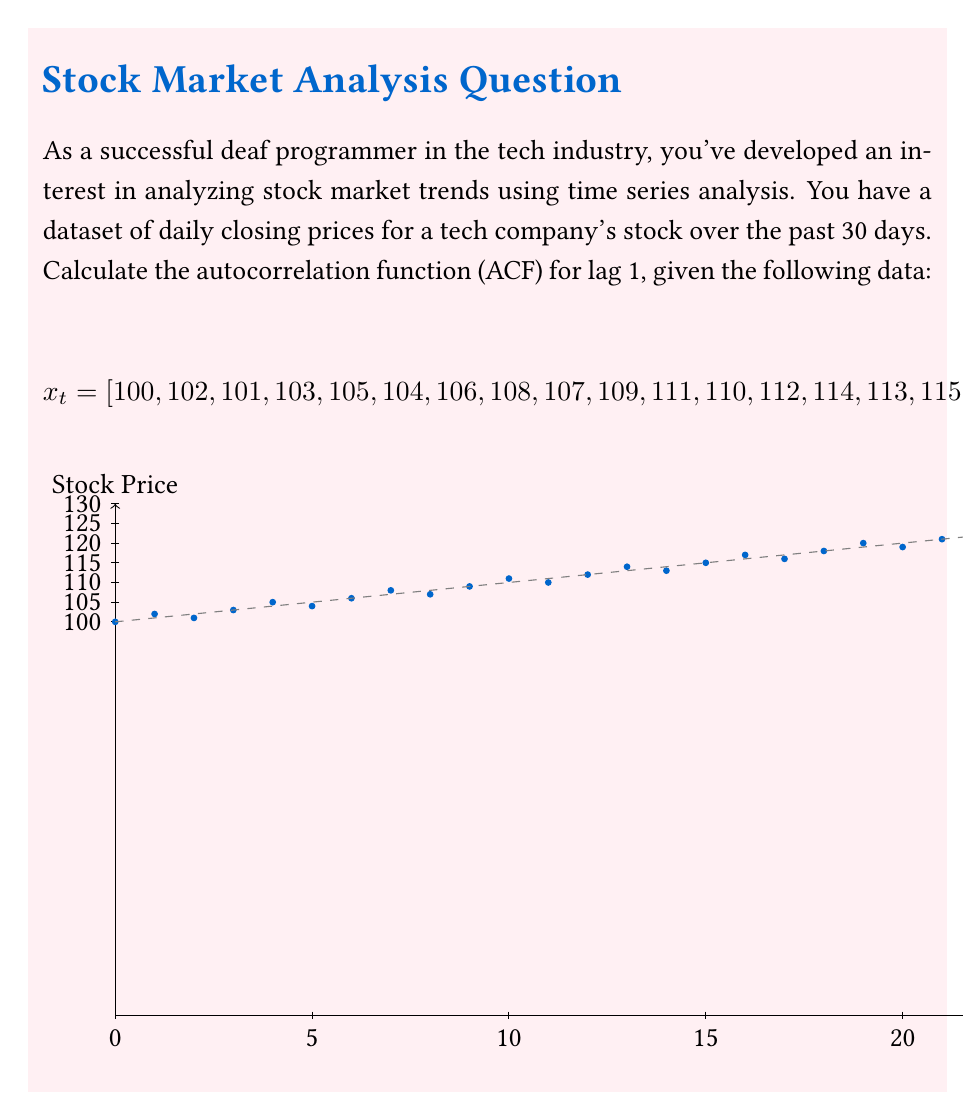Give your solution to this math problem. To calculate the autocorrelation function (ACF) for lag 1, we'll follow these steps:

1) First, calculate the mean of the time series:
   $$\bar{x} = \frac{1}{N}\sum_{t=1}^N x_t = 114.5$$

2) Calculate the variance of the time series:
   $$\sigma^2 = \frac{1}{N}\sum_{t=1}^N (x_t - \bar{x})^2 = 82.25$$

3) For lag 1, we need to calculate the autocovariance:
   $$\gamma(1) = \frac{1}{N-1}\sum_{t=1}^{N-1} (x_t - \bar{x})(x_{t+1} - \bar{x})$$

4) Calculate the sum in the autocovariance formula:
   $$(100 - 114.5)(102 - 114.5) + (102 - 114.5)(101 - 114.5) + ... + (127 - 114.5)(129 - 114.5)$$
   This sum equals 2298.5

5) Divide by (N-1) to get the autocovariance:
   $$\gamma(1) = \frac{2298.5}{29} = 79.26$$

6) The autocorrelation function for lag 1 is the autocovariance divided by the variance:
   $$ACF(1) = \frac{\gamma(1)}{\sigma^2} = \frac{79.26}{82.25} \approx 0.964$$
Answer: $ACF(1) \approx 0.964$ 